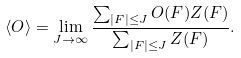<formula> <loc_0><loc_0><loc_500><loc_500>\langle O \rangle = \lim _ { J \to \infty } \frac { \sum _ { | F | \leq J } O ( F ) Z ( F ) } { \sum _ { | F | \leq J } Z ( F ) } .</formula> 